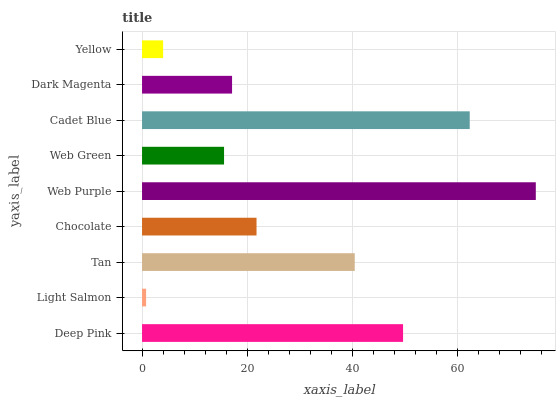Is Light Salmon the minimum?
Answer yes or no. Yes. Is Web Purple the maximum?
Answer yes or no. Yes. Is Tan the minimum?
Answer yes or no. No. Is Tan the maximum?
Answer yes or no. No. Is Tan greater than Light Salmon?
Answer yes or no. Yes. Is Light Salmon less than Tan?
Answer yes or no. Yes. Is Light Salmon greater than Tan?
Answer yes or no. No. Is Tan less than Light Salmon?
Answer yes or no. No. Is Chocolate the high median?
Answer yes or no. Yes. Is Chocolate the low median?
Answer yes or no. Yes. Is Yellow the high median?
Answer yes or no. No. Is Tan the low median?
Answer yes or no. No. 